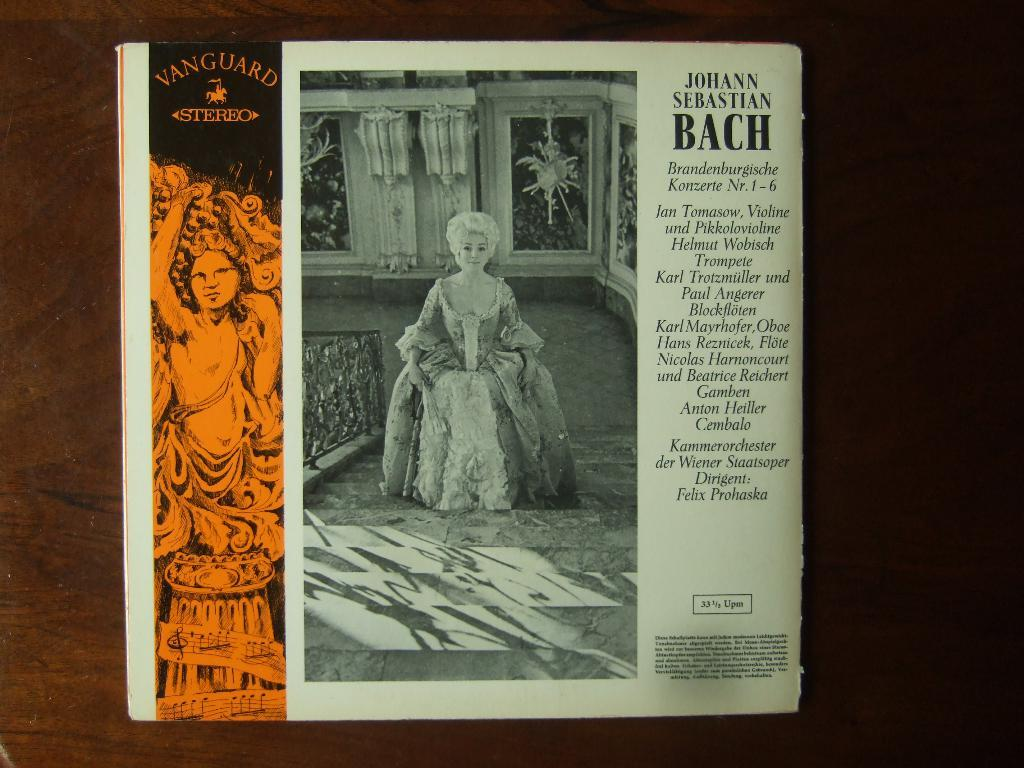<image>
Relay a brief, clear account of the picture shown. the word Bach that is on a magazone 